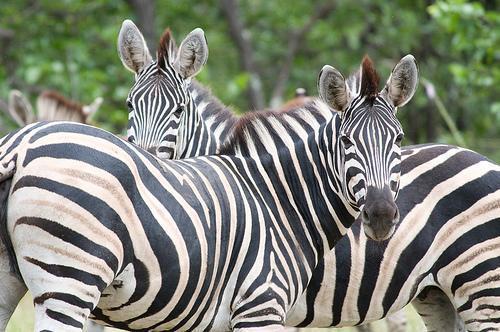How many zebras looking at the camera?
Give a very brief answer. 2. 